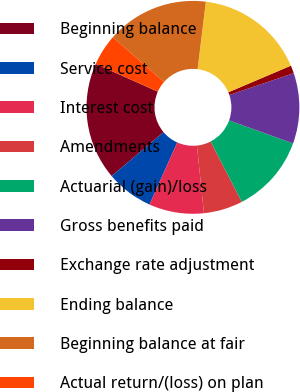Convert chart to OTSL. <chart><loc_0><loc_0><loc_500><loc_500><pie_chart><fcel>Beginning balance<fcel>Service cost<fcel>Interest cost<fcel>Amendments<fcel>Actuarial (gain)/loss<fcel>Gross benefits paid<fcel>Exchange rate adjustment<fcel>Ending balance<fcel>Beginning balance at fair<fcel>Actual return/(loss) on plan<nl><fcel>17.86%<fcel>7.14%<fcel>8.33%<fcel>5.95%<fcel>11.9%<fcel>10.71%<fcel>1.19%<fcel>16.67%<fcel>15.48%<fcel>4.76%<nl></chart> 